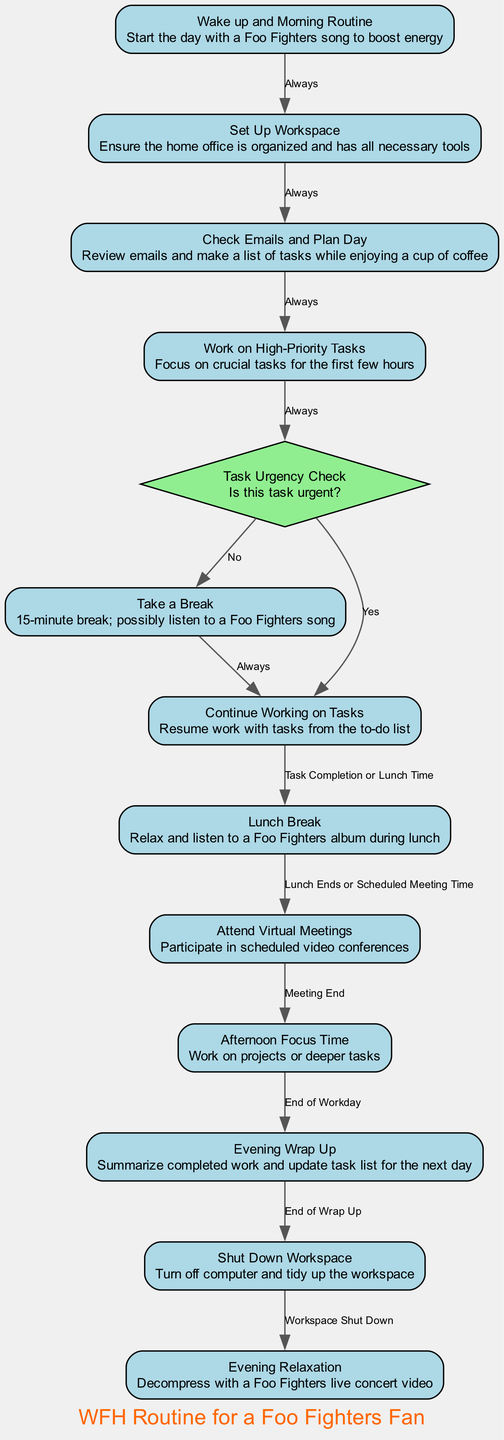What is the first activity in the diagram? The diagram indicates that the first activity, with an ID of "1," is labeled "Wake up and Morning Routine." This is the starting point from where the flow begins.
Answer: Wake up and Morning Routine How many activities are there in total? By counting the individual entries listed in the activities section of the diagram, we find there are 12 distinct activities depicted.
Answer: 12 What activity follows after the "Check Emails and Plan Day"? According to the flow sequence, after "Check Emails and Plan Day," which corresponds to ID "3," the next activity is "Work on High-Priority Tasks," labeled as ID "4."
Answer: Work on High-Priority Tasks What is the decision made after working on high-priority tasks? The decision flow specified right after working on high-priority tasks (ID "4") is to check for urgency, detailed as the "Task Urgency Check," which corresponds to decision ID "D1."
Answer: Task Urgency Check What happens if a task is not urgent according to the diagram? If a task is determined to be not urgent (the decision where the label is "No"), the flow directs the sequence to "Take a Break," which is listed as activity ID "5."
Answer: Take a Break How does the flow continue after a lunch break? Following the "Lunch Break," labeled as activity ID "7," the flow will progress to "Attend Virtual Meetings," designated as activity ID "8," upon lunch ending or scheduled meeting time.
Answer: Attend Virtual Meetings What is indicated when the workday is complete? At the end of the workday, as indicated in the flow from "Afternoon Focus Time" (ID "9") to "Evening Wrap Up" (ID "10"), the final activities transition to completing the day's tasks and summarizing the work completed.
Answer: Evening Wrap Up Which activity relates to shutting down the workspace? The activity that corresponds to shutting down the workspace is "Shut Down Workspace," identified with the ID "11," directly following the evening wrap-up process.
Answer: Shut Down Workspace 